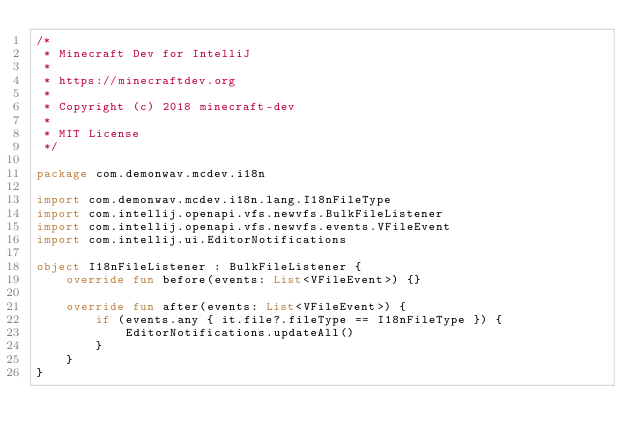Convert code to text. <code><loc_0><loc_0><loc_500><loc_500><_Kotlin_>/*
 * Minecraft Dev for IntelliJ
 *
 * https://minecraftdev.org
 *
 * Copyright (c) 2018 minecraft-dev
 *
 * MIT License
 */

package com.demonwav.mcdev.i18n

import com.demonwav.mcdev.i18n.lang.I18nFileType
import com.intellij.openapi.vfs.newvfs.BulkFileListener
import com.intellij.openapi.vfs.newvfs.events.VFileEvent
import com.intellij.ui.EditorNotifications

object I18nFileListener : BulkFileListener {
    override fun before(events: List<VFileEvent>) {}

    override fun after(events: List<VFileEvent>) {
        if (events.any { it.file?.fileType == I18nFileType }) {
            EditorNotifications.updateAll()
        }
    }
}
</code> 